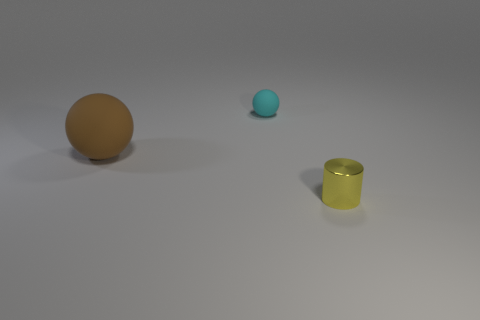Is there any other thing that has the same shape as the yellow thing?
Your answer should be very brief. No. Is the size of the matte sphere that is on the left side of the small cyan object the same as the matte object to the right of the large object?
Your answer should be compact. No. There is a thing in front of the big matte ball in front of the cyan ball; what color is it?
Offer a very short reply. Yellow. There is a sphere that is the same size as the shiny cylinder; what is its material?
Your response must be concise. Rubber. What number of metallic things are small green blocks or large brown spheres?
Offer a terse response. 0. What color is the thing that is in front of the tiny cyan matte sphere and to the left of the cylinder?
Keep it short and to the point. Brown. How many cyan objects are on the left side of the small ball?
Give a very brief answer. 0. What is the brown thing made of?
Give a very brief answer. Rubber. What color is the small object that is in front of the sphere in front of the small cyan matte object that is behind the large thing?
Your answer should be very brief. Yellow. How many rubber spheres have the same size as the yellow shiny cylinder?
Your answer should be compact. 1. 